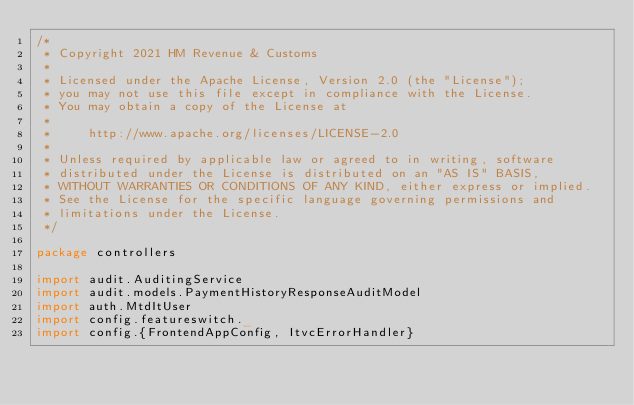<code> <loc_0><loc_0><loc_500><loc_500><_Scala_>/*
 * Copyright 2021 HM Revenue & Customs
 *
 * Licensed under the Apache License, Version 2.0 (the "License");
 * you may not use this file except in compliance with the License.
 * You may obtain a copy of the License at
 *
 *     http://www.apache.org/licenses/LICENSE-2.0
 *
 * Unless required by applicable law or agreed to in writing, software
 * distributed under the License is distributed on an "AS IS" BASIS,
 * WITHOUT WARRANTIES OR CONDITIONS OF ANY KIND, either express or implied.
 * See the License for the specific language governing permissions and
 * limitations under the License.
 */

package controllers

import audit.AuditingService
import audit.models.PaymentHistoryResponseAuditModel
import auth.MtdItUser
import config.featureswitch._
import config.{FrontendAppConfig, ItvcErrorHandler}</code> 